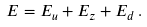Convert formula to latex. <formula><loc_0><loc_0><loc_500><loc_500>E = E _ { u } + E _ { z } + E _ { d } \, .</formula> 